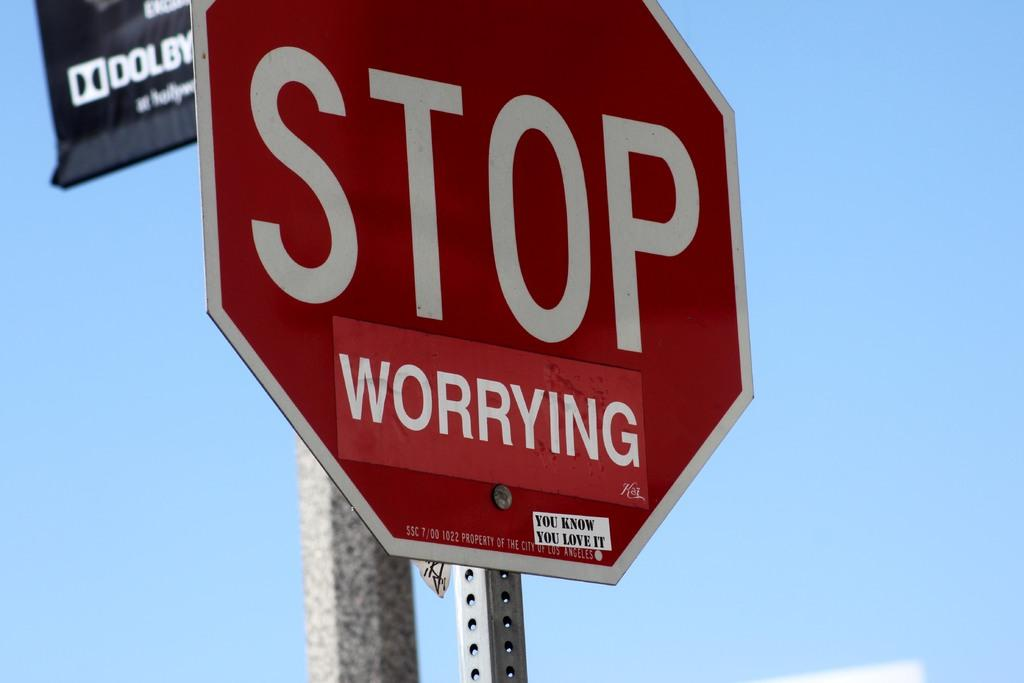<image>
Render a clear and concise summary of the photo. a stop sign that is next to another pole 